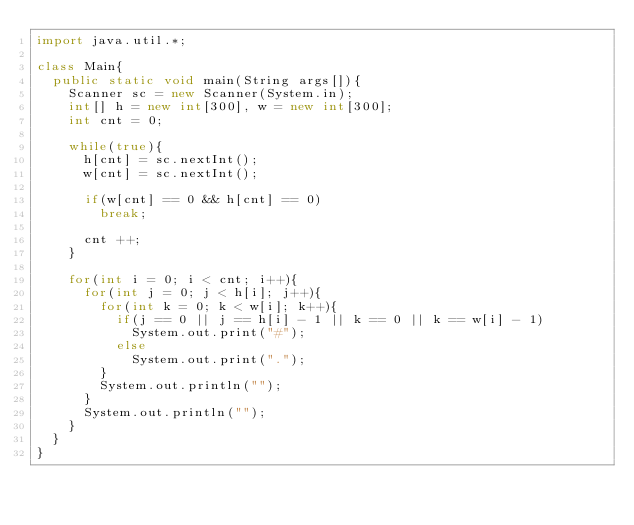<code> <loc_0><loc_0><loc_500><loc_500><_Java_>import java.util.*;

class Main{
	public static void main(String args[]){
		Scanner sc = new Scanner(System.in);
		int[] h = new int[300], w = new int[300];
		int cnt = 0;
		
		while(true){
			h[cnt] = sc.nextInt();
			w[cnt] = sc.nextInt();
			
			if(w[cnt] == 0 && h[cnt] == 0)
				break;
			
			cnt ++;
		}
		
		for(int i = 0; i < cnt; i++){
			for(int j = 0; j < h[i]; j++){
				for(int k = 0; k < w[i]; k++){
					if(j == 0 || j == h[i] - 1 || k == 0 || k == w[i] - 1)
						System.out.print("#");
					else
						System.out.print(".");
				}
				System.out.println("");
			}
			System.out.println("");
		}
	}
}</code> 